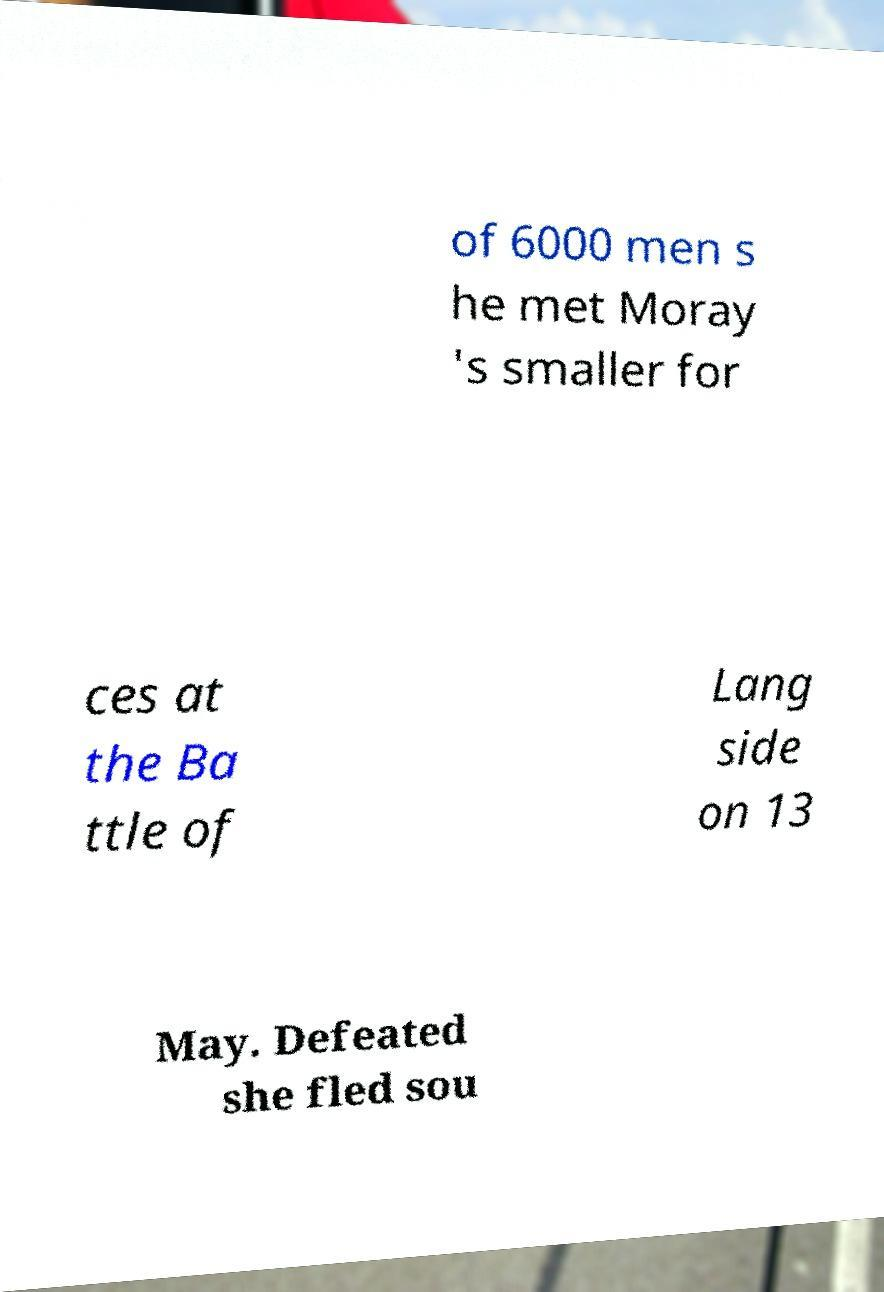Could you assist in decoding the text presented in this image and type it out clearly? of 6000 men s he met Moray 's smaller for ces at the Ba ttle of Lang side on 13 May. Defeated she fled sou 